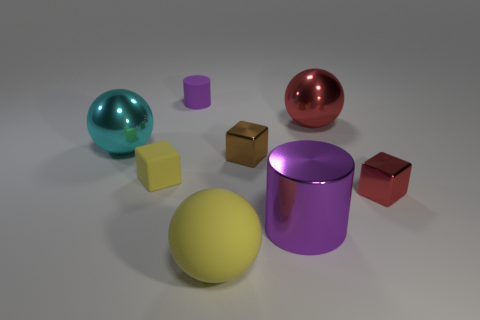Add 1 yellow rubber cubes. How many objects exist? 9 Subtract all spheres. How many objects are left? 5 Subtract all small rubber objects. Subtract all matte cylinders. How many objects are left? 5 Add 5 red cubes. How many red cubes are left? 6 Add 4 red metallic things. How many red metallic things exist? 6 Subtract 1 red cubes. How many objects are left? 7 